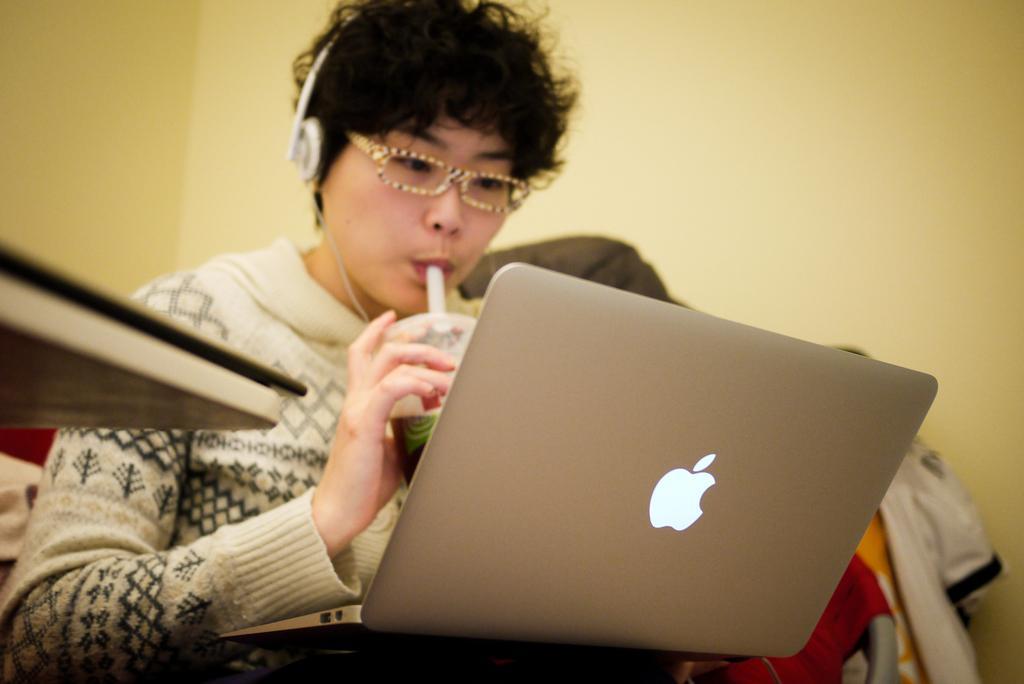Can you describe this image briefly? As we can see in the image there is a yellow color wall, table, cloths, a woman wearing white color jacket, spectacles and holding glass. In the front there is laptop. 